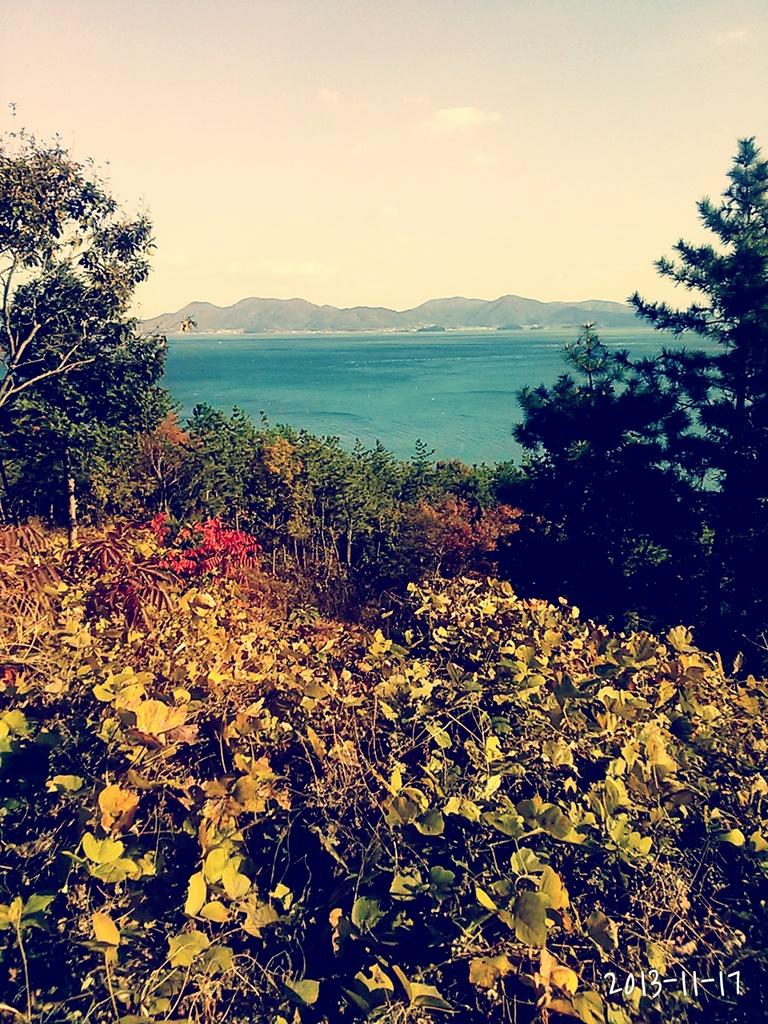What type of natural elements can be seen in the image? Plants, trees, the sea, hills, and the sky are visible in the image. Can you describe the landscape in the image? The image features a landscape with plants, trees, hills, and the sea. What is the condition of the sky in the image? The sky is visible in the image. What invention is being demonstrated in the image? There is no invention being demonstrated in the image; it features a natural landscape with plants, trees, the sea, hills, and the sky. Can you tell me how many bars of soap are visible in the image? There are no bars of soap present in the image. 